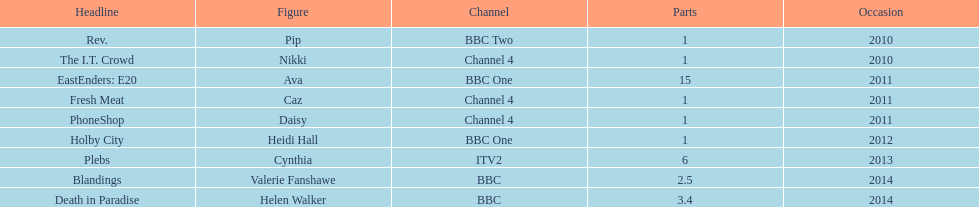Were there more than four episodes that featured cynthia? Yes. 